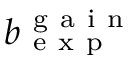Convert formula to latex. <formula><loc_0><loc_0><loc_500><loc_500>b _ { e x p } ^ { g a i n }</formula> 